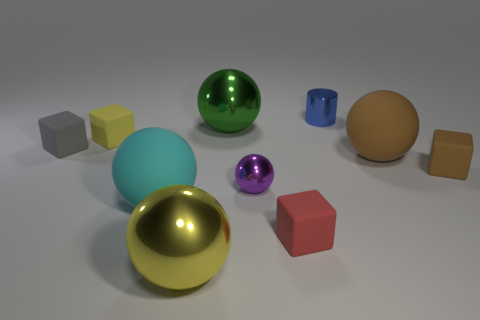There is a object that is both left of the tiny brown rubber thing and right of the tiny metal cylinder; what color is it?
Your answer should be very brief. Brown. There is a large shiny ball that is in front of the small red matte thing; is there a green metallic thing left of it?
Make the answer very short. No. Are there the same number of big metal objects that are right of the brown block and green matte balls?
Your response must be concise. Yes. How many rubber objects are behind the large matte thing that is behind the tiny brown thing behind the tiny purple shiny ball?
Your answer should be very brief. 2. Are there any metallic cylinders of the same size as the gray block?
Keep it short and to the point. Yes. Is the number of red rubber objects that are to the left of the tiny purple metallic thing less than the number of cubes?
Your answer should be compact. Yes. What material is the thing that is behind the big shiny object behind the small rubber thing that is on the right side of the cylinder made of?
Provide a short and direct response. Metal. Are there more big yellow shiny objects that are on the right side of the small brown thing than big objects to the right of the big yellow thing?
Ensure brevity in your answer.  No. What number of metallic things are small cylinders or small balls?
Your response must be concise. 2. There is a yellow object that is in front of the cyan sphere; what material is it?
Offer a very short reply. Metal. 